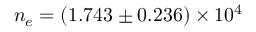Convert formula to latex. <formula><loc_0><loc_0><loc_500><loc_500>n _ { e } = ( 1 . 7 4 3 \pm 0 . 2 3 6 ) \times 1 0 ^ { 4 }</formula> 